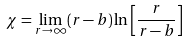<formula> <loc_0><loc_0><loc_500><loc_500>\chi = \lim _ { r \rightarrow \infty } ( r - b ) \ln \left [ \frac { r } { r - b } \right ]</formula> 